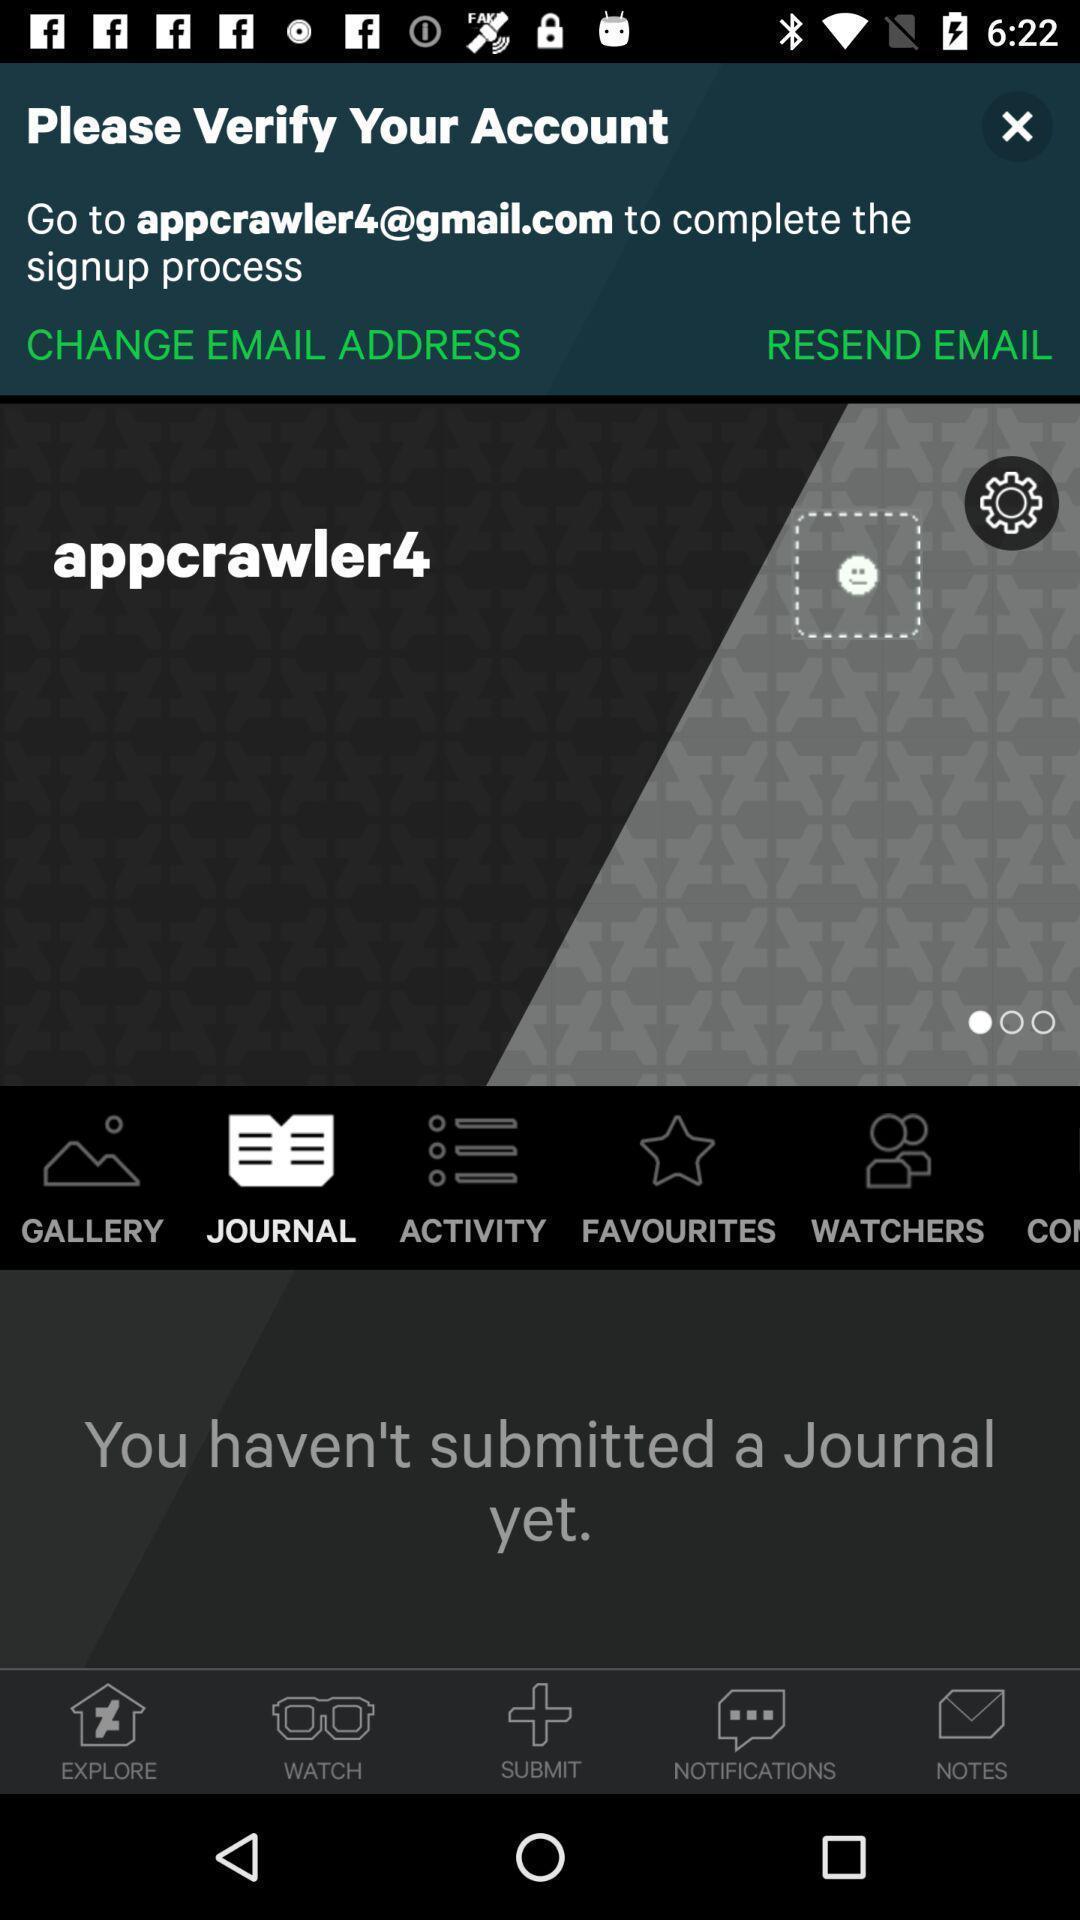What details can you identify in this image? Verifying account address in the page. 